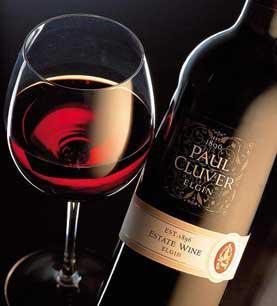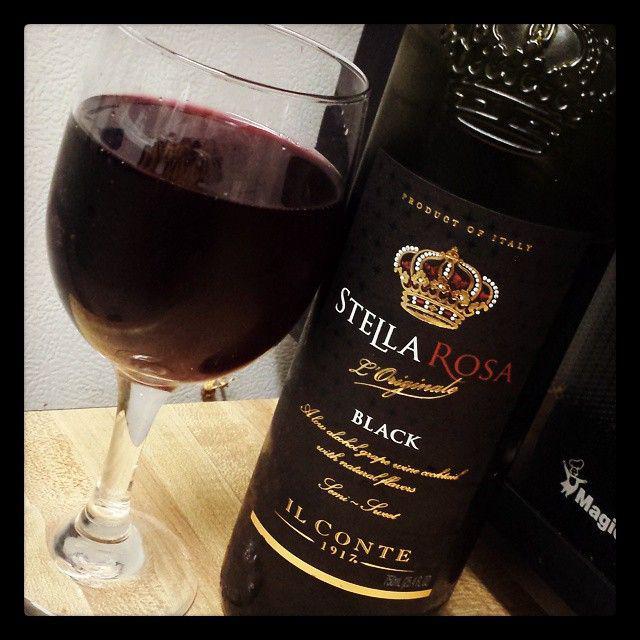The first image is the image on the left, the second image is the image on the right. For the images displayed, is the sentence "In one of the images there are two wine bottles next to each other." factually correct? Answer yes or no. No. 